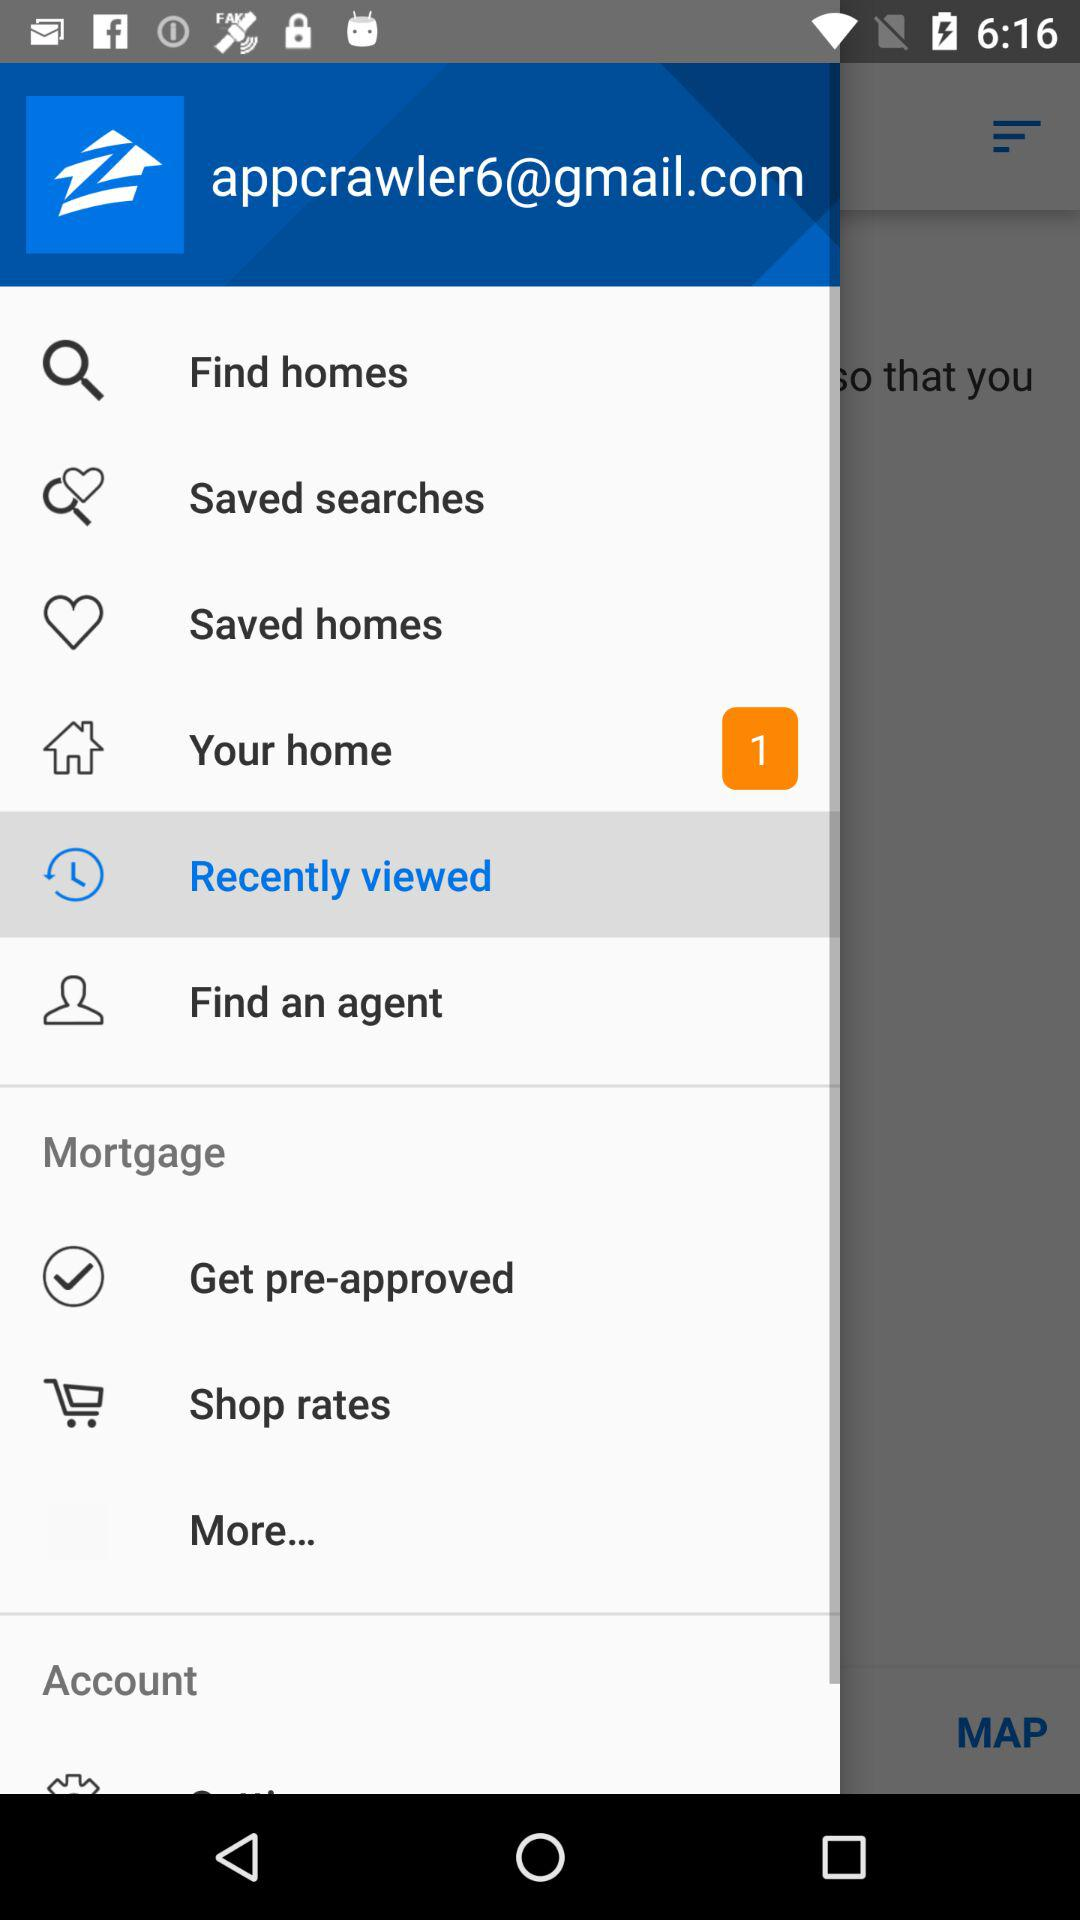Which option is selected? The selected option is "Recently viewed". 